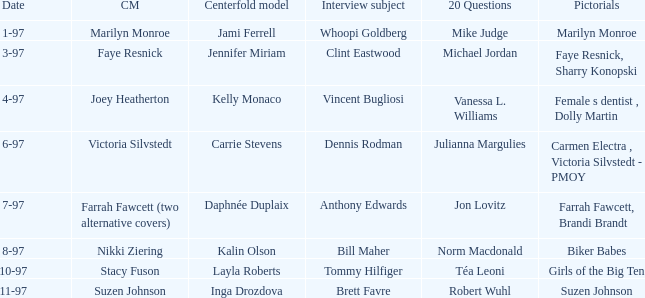In a marilyn monroe pictorial, who was the model chosen for the centerfold? Jami Ferrell. 